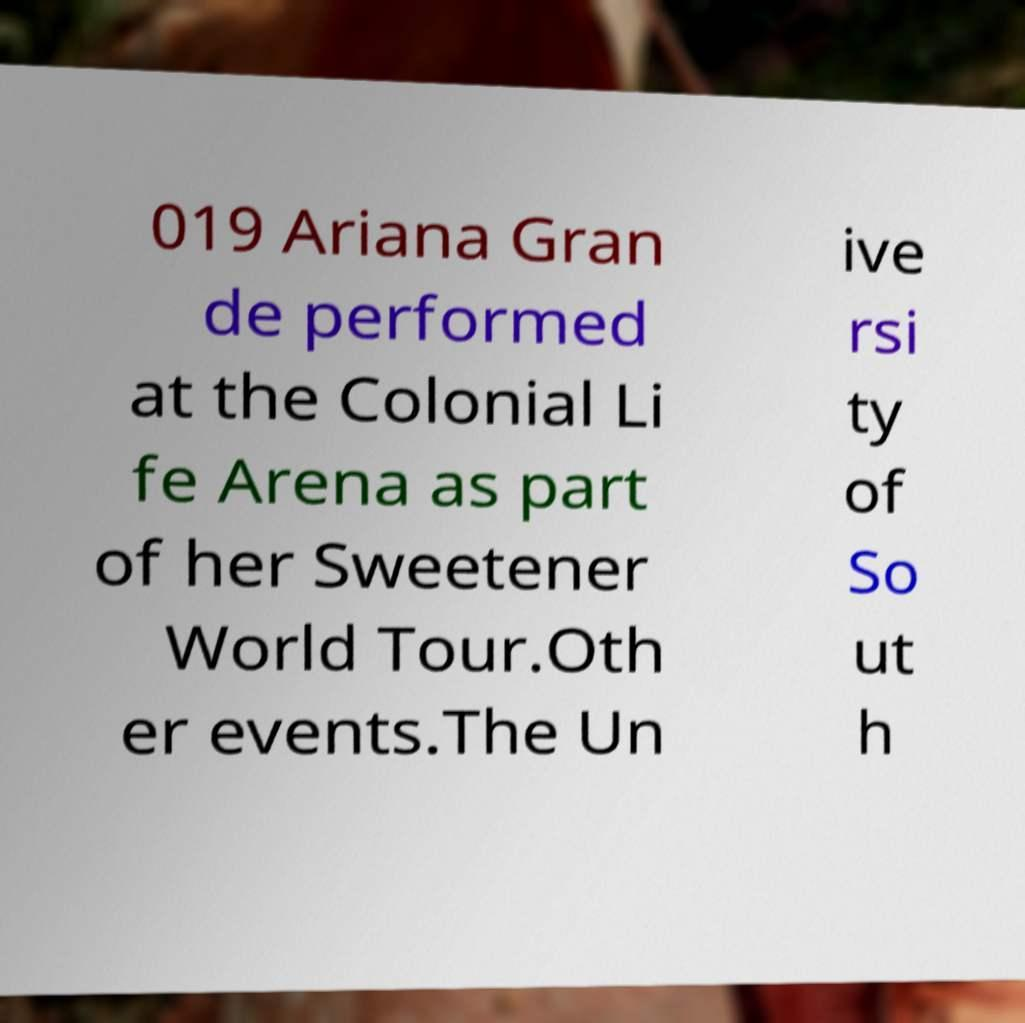Could you assist in decoding the text presented in this image and type it out clearly? 019 Ariana Gran de performed at the Colonial Li fe Arena as part of her Sweetener World Tour.Oth er events.The Un ive rsi ty of So ut h 